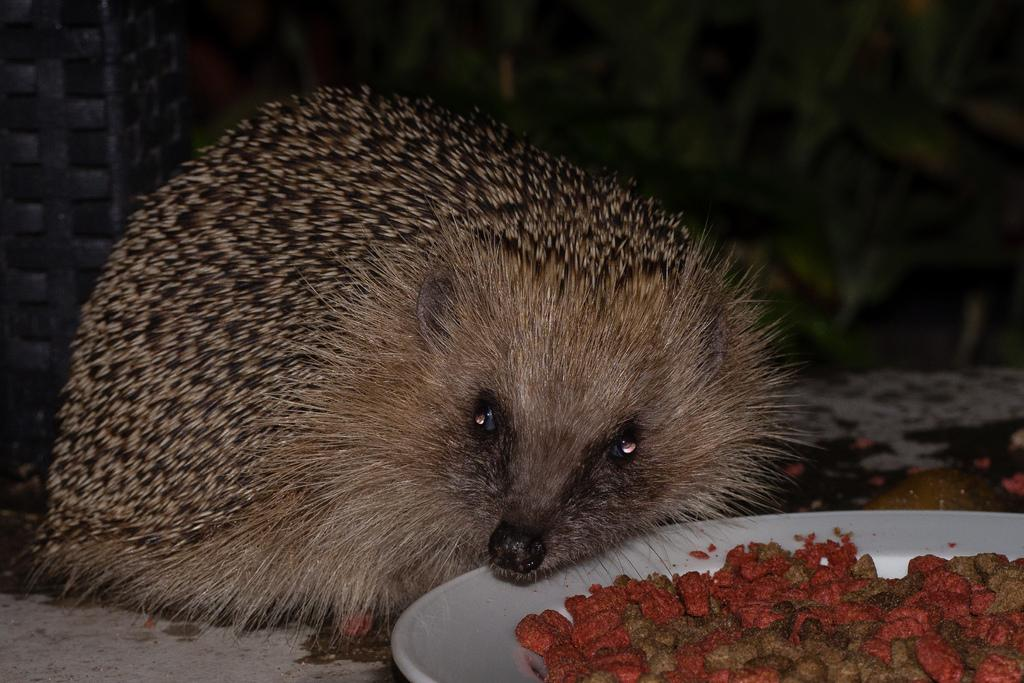What type of animal is on the floor in the image? There is a rodent on the floor in the image. What is the rodent near in the image? The rodent is near a white color plate. What is on the white color plate? The white color plate has food items on it. How would you describe the background of the image? The background of the image is dark in color. Can you see any quills in the image? There are no quills visible in the image. Is there a fire burning in the background of the image? There is no fire present in the image. 